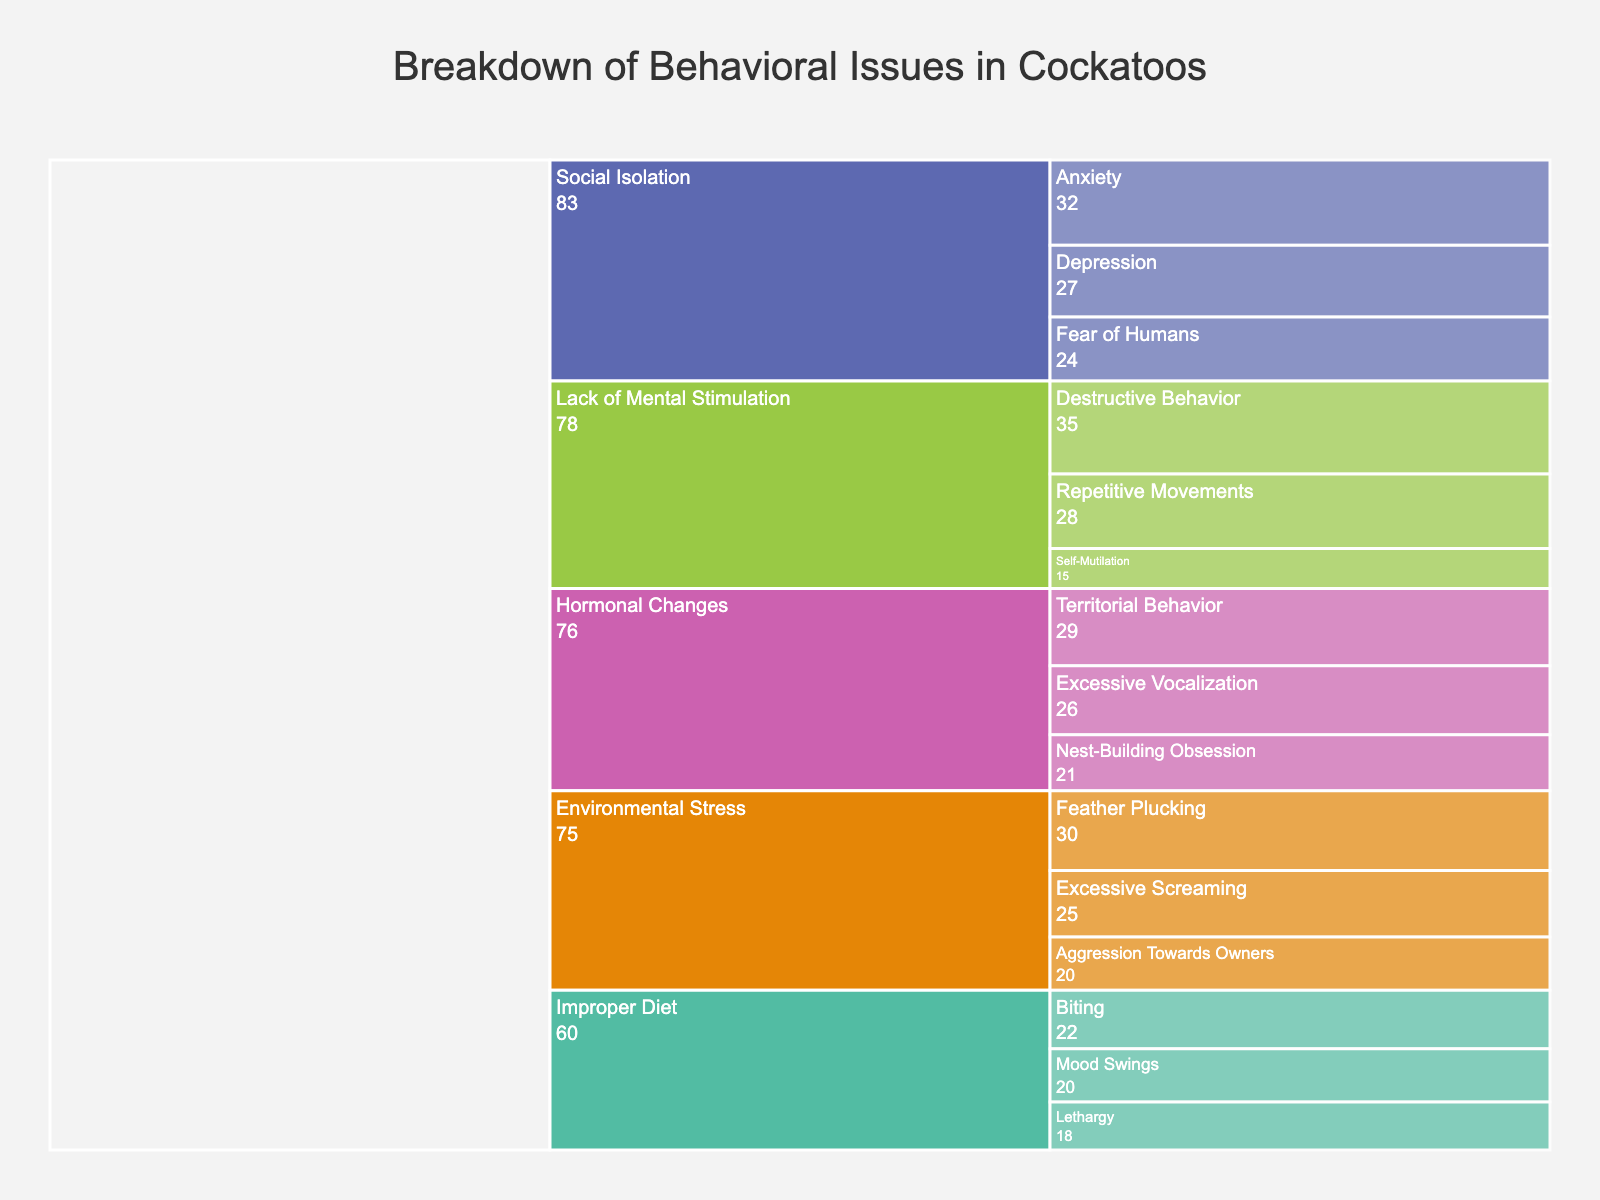How many specific issues are categorized under "Environmental Stress"? Look at the branch labeled "Environmental Stress" and count the number of specific issues branching out from it. There are three: Feather Plucking, Excessive Screaming, and Aggression Towards Owners.
Answer: 3 Which specific issue has the highest frequency under "Lack of Mental Stimulation"? Examine the issues categorized under "Lack of Mental Stimulation" and compare their frequencies. Destructive Behavior has the highest frequency of 35.
Answer: Destructive Behavior Compare the frequencies of "Fear of Humans" and "Territorial Behavior". Which one is higher? Look at the branches for "Fear of Humans" under "Social Isolation" and "Territorial Behavior" under "Hormonal Changes". "Fear of Humans" has a frequency of 24, while "Territorial Behavior" has a frequency of 29. Hence, "Territorial Behavior" is higher.
Answer: Territorial Behavior What is the title of the icicle chart? The title is usually found at the top of the chart. It is "Breakdown of Behavioral Issues in Cockatoos".
Answer: Breakdown of Behavioral Issues in Cockatoos What is the combined frequency of "Biting" and "Mood Swings"? Locate the frequencies of "Biting" (22) and "Mood Swings" (20) under "Improper Diet". Sum these frequencies: 22 + 20 = 42.
Answer: 42 Which specific issue related to "Social Isolation" has the highest frequency? Inspect the "Social Isolation" branch and compare the frequencies of "Depression", "Anxiety", and "Fear of Humans". "Anxiety" has the highest frequency of 32.
Answer: Anxiety Is the frequency of "Excessive Screaming" higher than "Excessive Vocalization"? Check the branches for "Excessive Screaming" under "Environmental Stress" and "Excessive Vocalization" under "Hormonal Changes". "Excessive Screaming" has a frequency of 25, and "Excessive Vocalization" has a frequency of 26. Thus, "Excessive Screaming" is not higher.
Answer: No What is the frequency of "Self-Mutilation" and which root cause does it belong to? Look for the "Self-Mutilation" issue and identify its frequency and root cause branch. "Self-Mutilation" has a frequency of 15 and belongs to "Lack of Mental Stimulation".
Answer: 15, Lack of Mental Stimulation How does the frequency of "Feather Plucking" compare to "Territorial Behavior"? Analyze the frequencies of "Feather Plucking" (30) under "Environmental Stress" and "Territorial Behavior" (29) under "Hormonal Changes". "Feather Plucking" is higher.
Answer: Feather Plucking is higher 